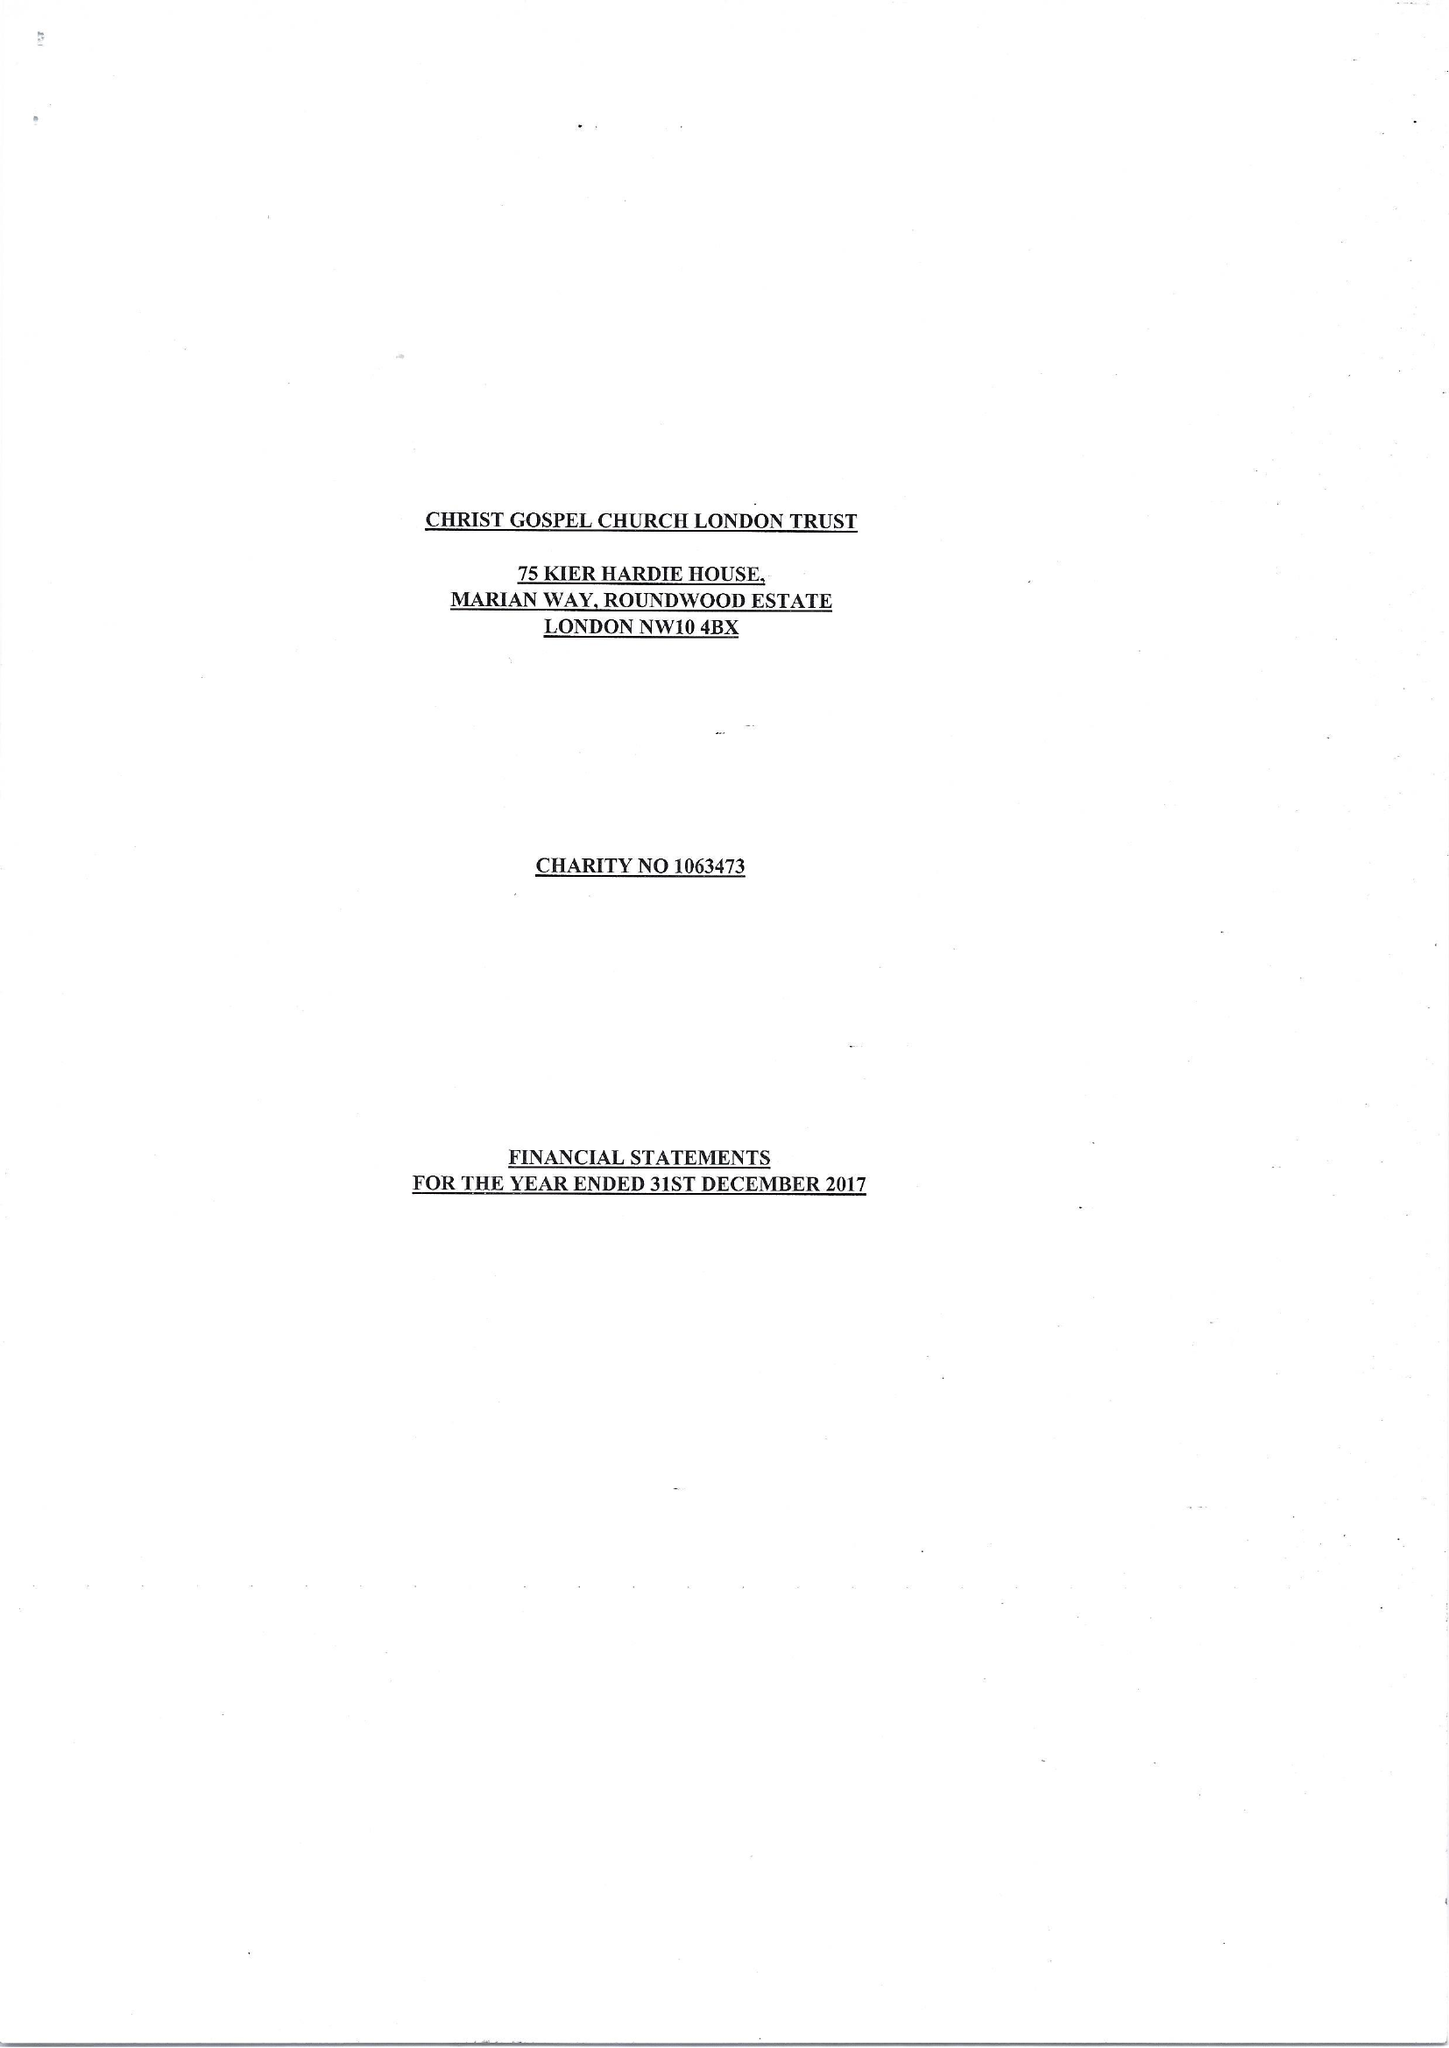What is the value for the address__post_town?
Answer the question using a single word or phrase. LONDON 